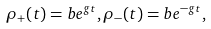Convert formula to latex. <formula><loc_0><loc_0><loc_500><loc_500>\rho _ { + } ( t ) = b e ^ { g t } , \rho _ { - } ( t ) = b e ^ { - g t } ,</formula> 